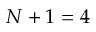<formula> <loc_0><loc_0><loc_500><loc_500>N + 1 = 4</formula> 